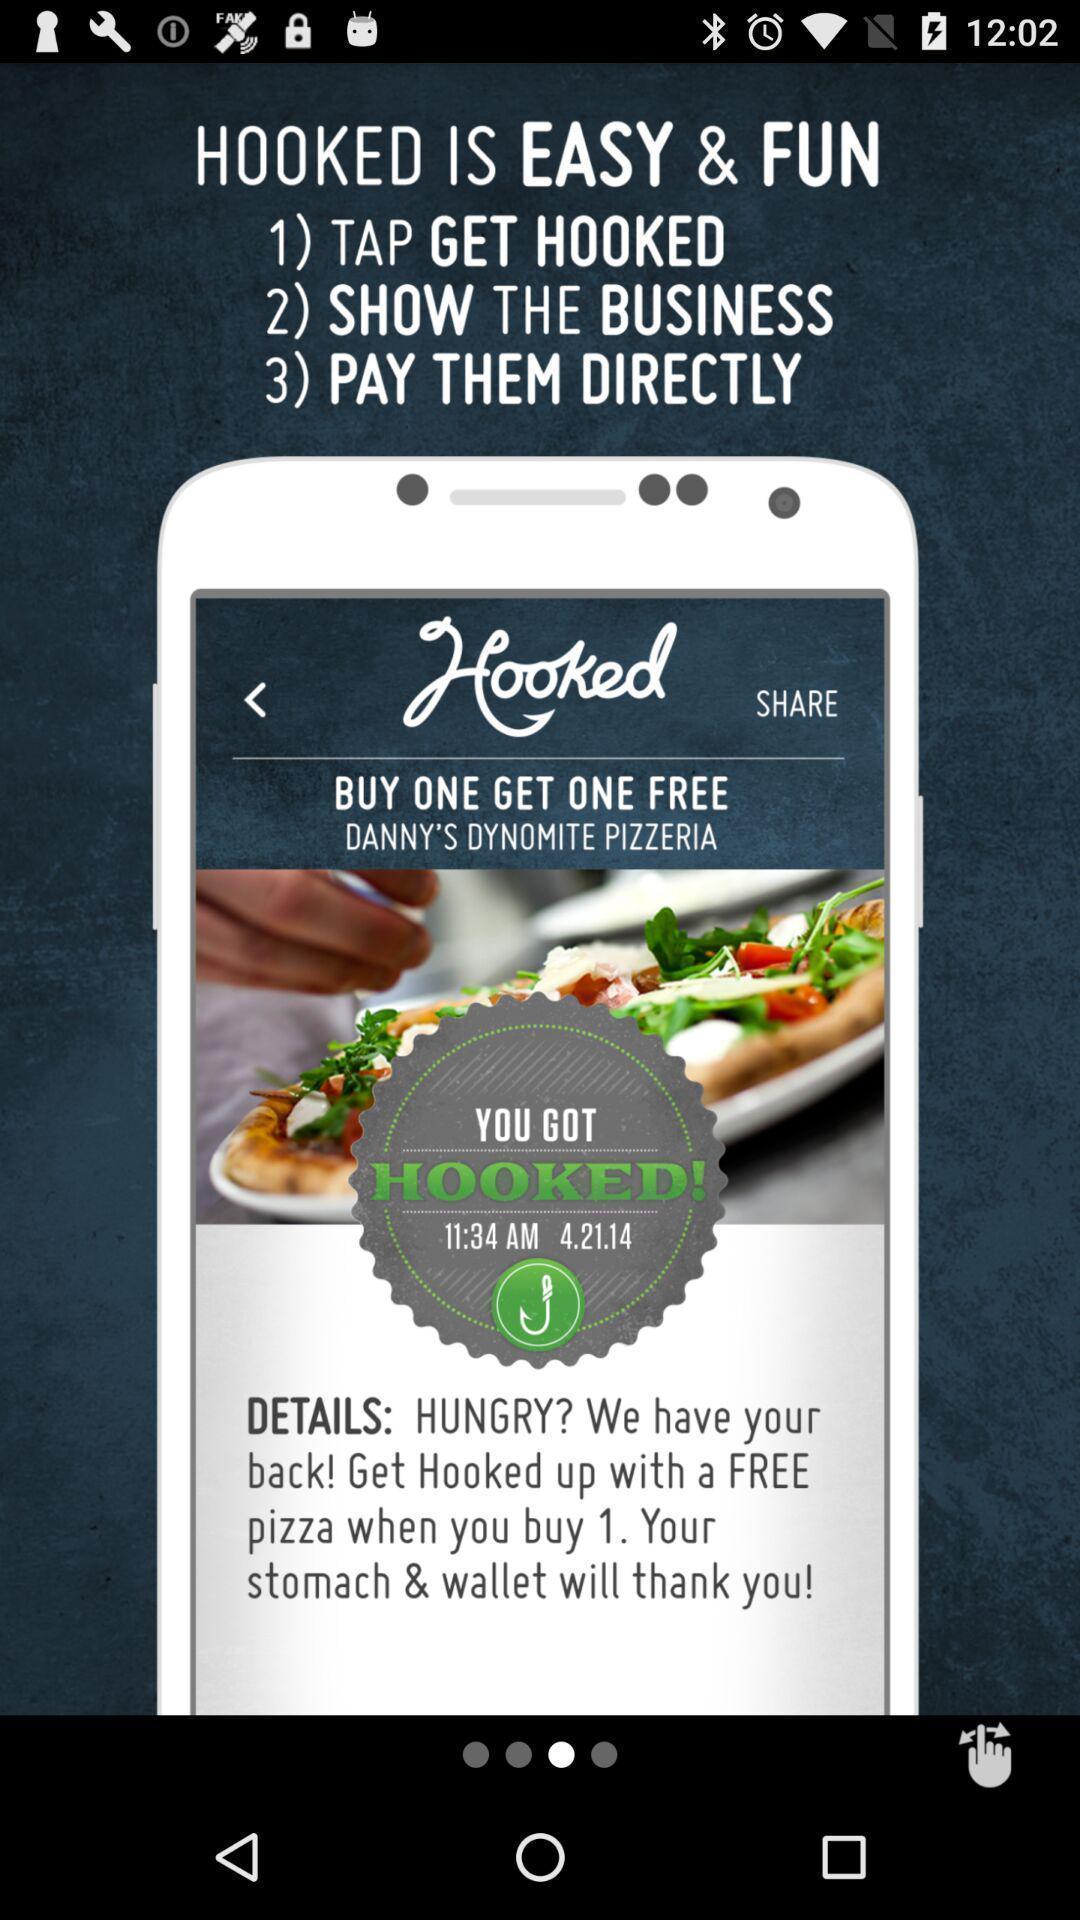Explain what's happening in this screen capture. Welcome page displayed of an food application. 